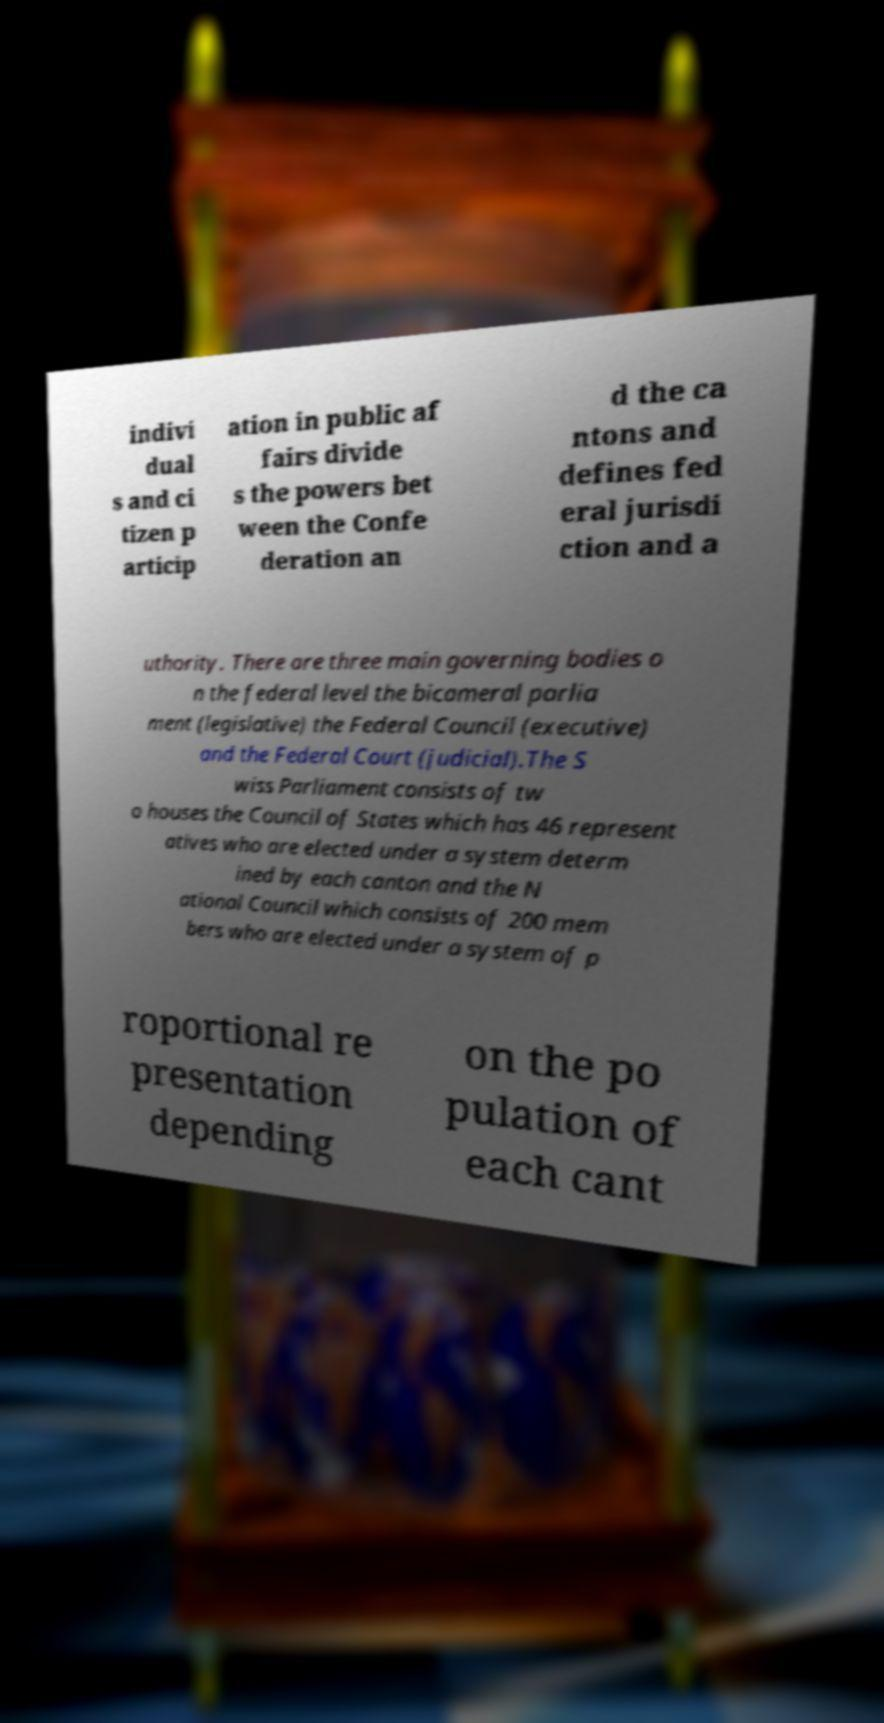I need the written content from this picture converted into text. Can you do that? indivi dual s and ci tizen p articip ation in public af fairs divide s the powers bet ween the Confe deration an d the ca ntons and defines fed eral jurisdi ction and a uthority. There are three main governing bodies o n the federal level the bicameral parlia ment (legislative) the Federal Council (executive) and the Federal Court (judicial).The S wiss Parliament consists of tw o houses the Council of States which has 46 represent atives who are elected under a system determ ined by each canton and the N ational Council which consists of 200 mem bers who are elected under a system of p roportional re presentation depending on the po pulation of each cant 